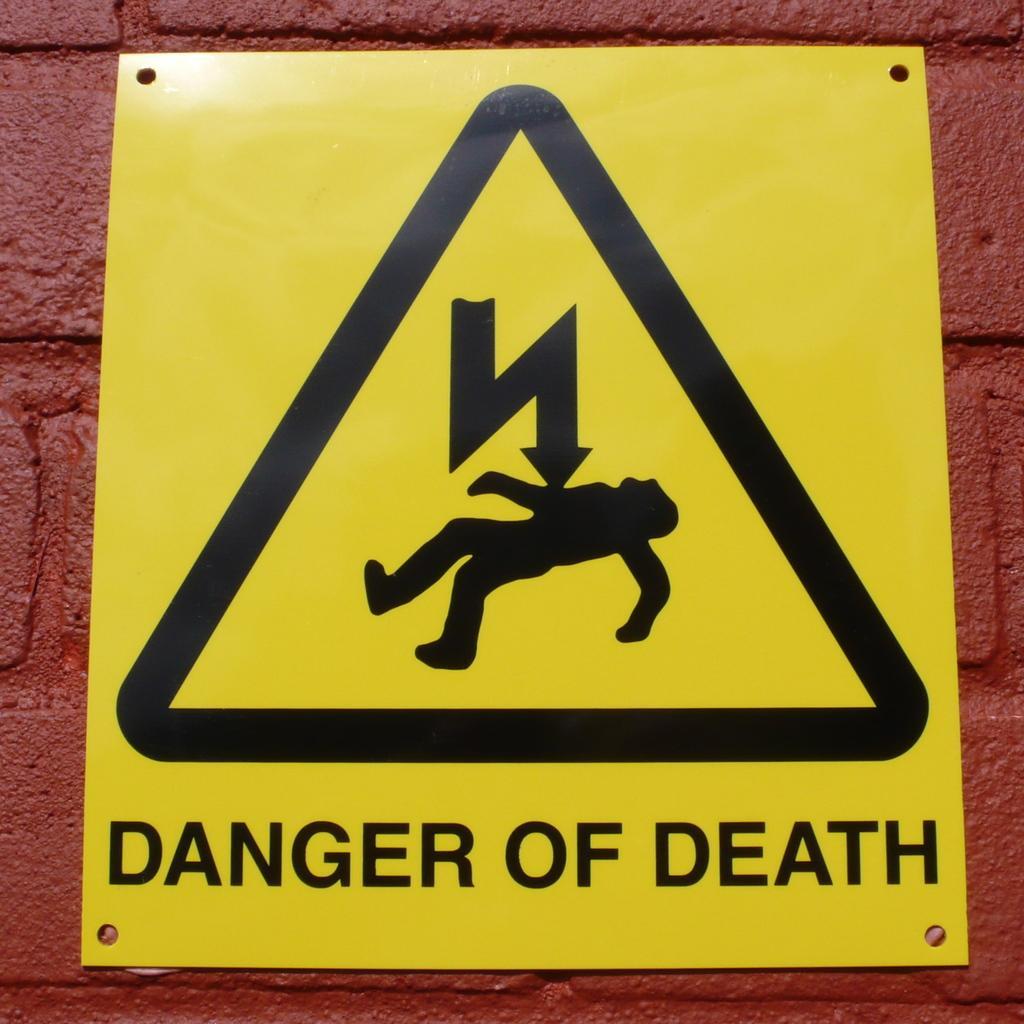Could you give a brief overview of what you see in this image? In the center of the image we can see sign board on the wall. 